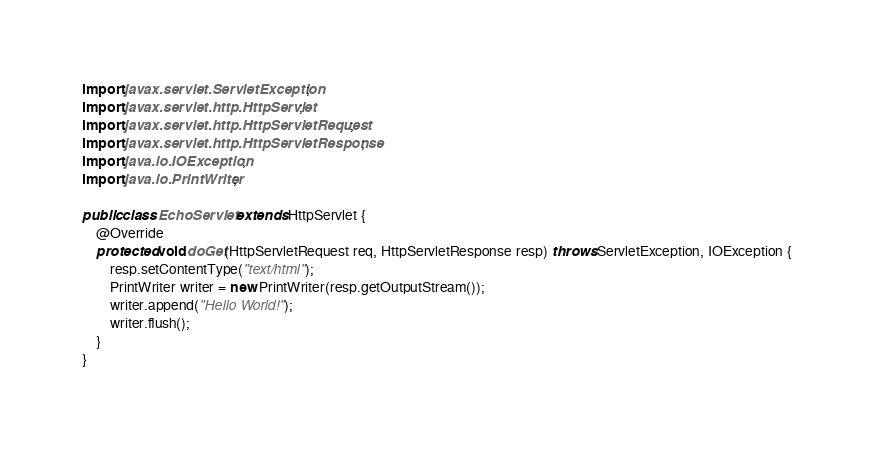Convert code to text. <code><loc_0><loc_0><loc_500><loc_500><_Java_>
import javax.servlet.ServletException;
import javax.servlet.http.HttpServlet;
import javax.servlet.http.HttpServletRequest;
import javax.servlet.http.HttpServletResponse;
import java.io.IOException;
import java.io.PrintWriter;

public class EchoServlet extends HttpServlet {
    @Override
    protected void doGet(HttpServletRequest req, HttpServletResponse resp) throws ServletException, IOException {
        resp.setContentType("text/html");
        PrintWriter writer = new PrintWriter(resp.getOutputStream());
        writer.append("Hello World!");
        writer.flush();
    }
}</code> 